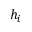<formula> <loc_0><loc_0><loc_500><loc_500>h _ { i }</formula> 